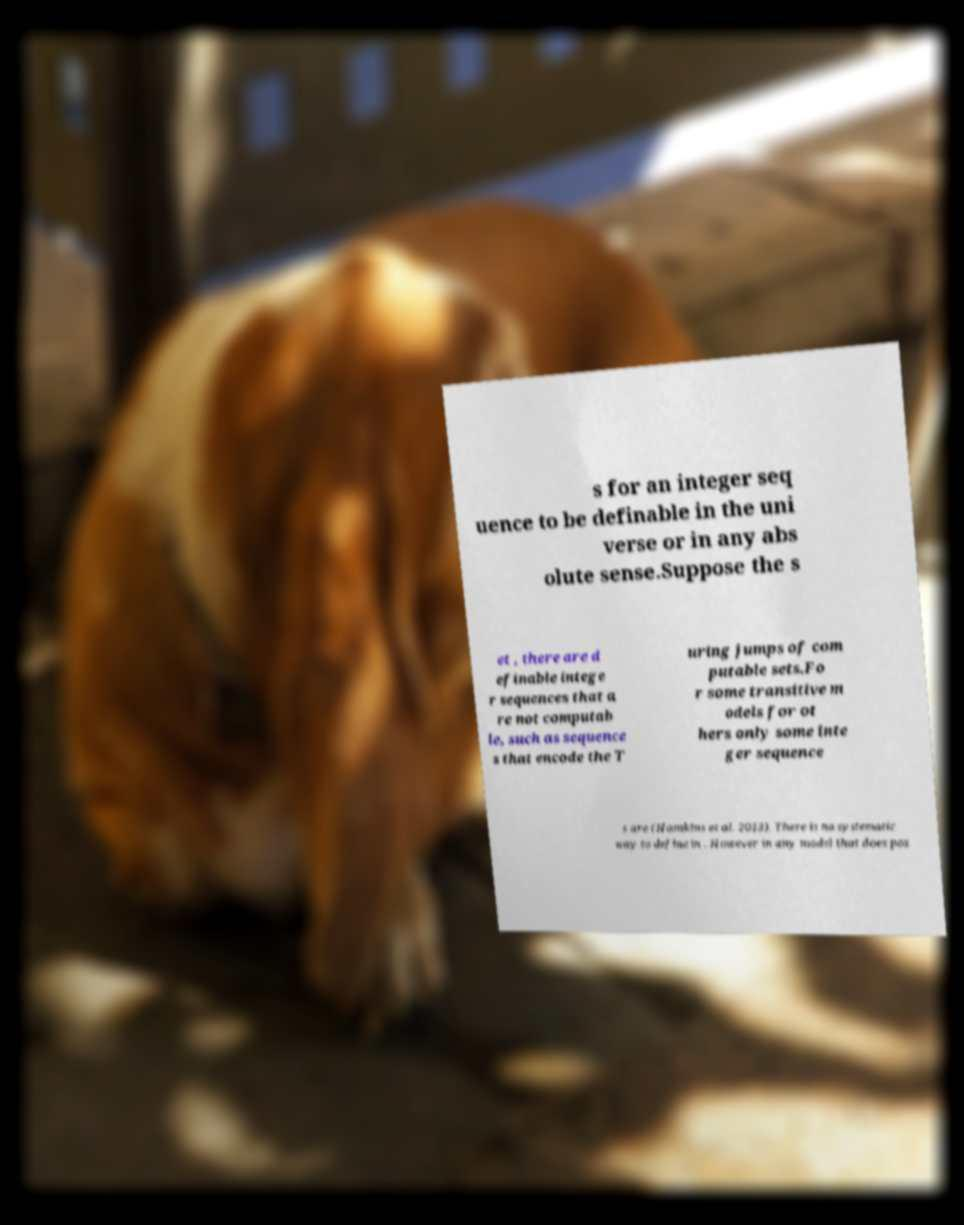For documentation purposes, I need the text within this image transcribed. Could you provide that? s for an integer seq uence to be definable in the uni verse or in any abs olute sense.Suppose the s et , there are d efinable intege r sequences that a re not computab le, such as sequence s that encode the T uring jumps of com putable sets.Fo r some transitive m odels for ot hers only some inte ger sequence s are (Hamkins et al. 2013). There is no systematic way to define in . However in any model that does pos 